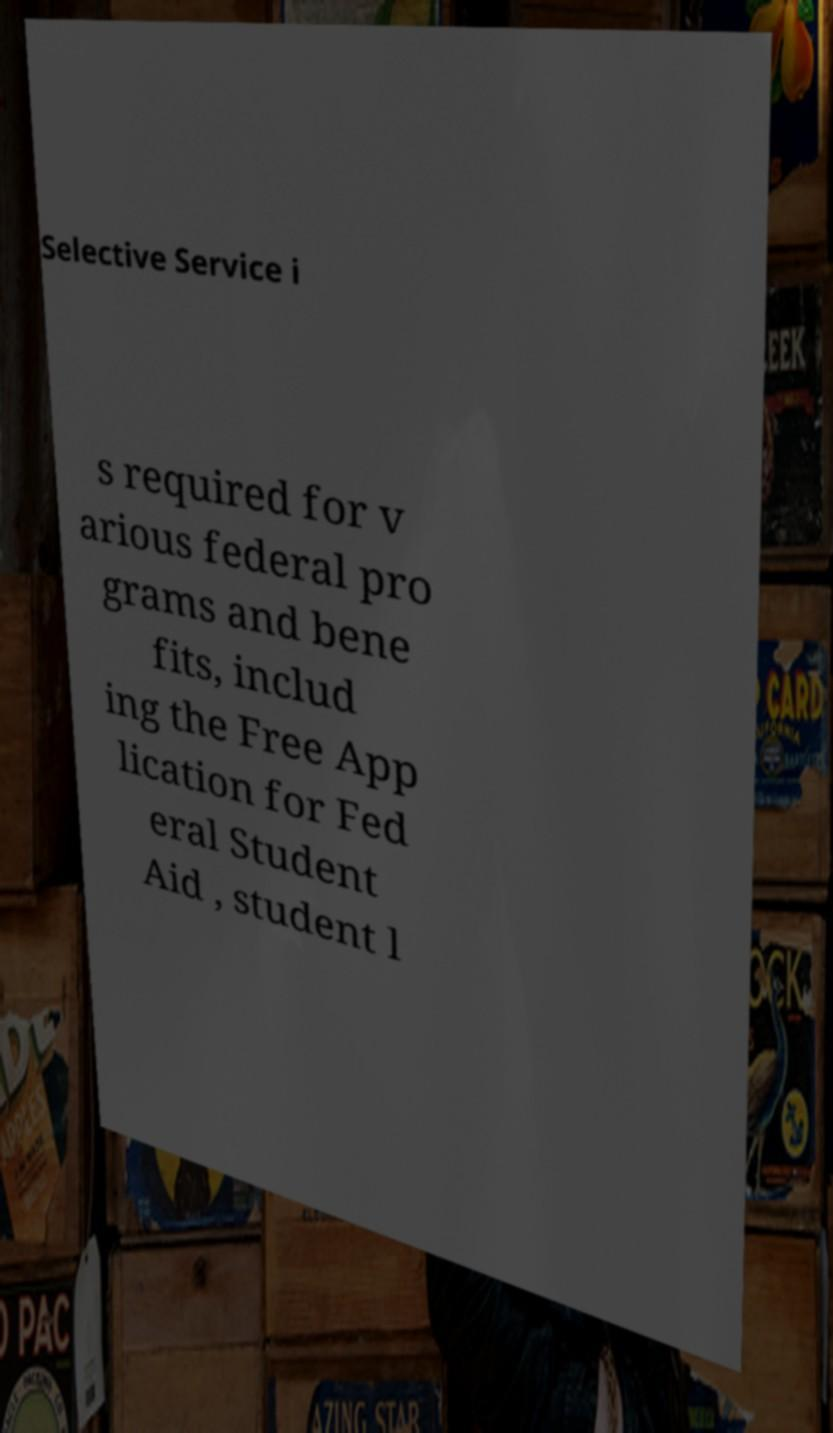Please read and relay the text visible in this image. What does it say? Selective Service i s required for v arious federal pro grams and bene fits, includ ing the Free App lication for Fed eral Student Aid , student l 